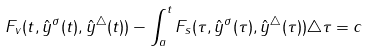<formula> <loc_0><loc_0><loc_500><loc_500>F _ { v } ( t , \hat { y } ^ { \sigma } ( t ) , \hat { y } ^ { \triangle } ( t ) ) - \int _ { a } ^ { t } F _ { s } ( \tau , \hat { y } ^ { \sigma } ( \tau ) , \hat { y } ^ { \triangle } ( \tau ) ) \triangle \tau = c</formula> 